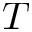<formula> <loc_0><loc_0><loc_500><loc_500>T</formula> 